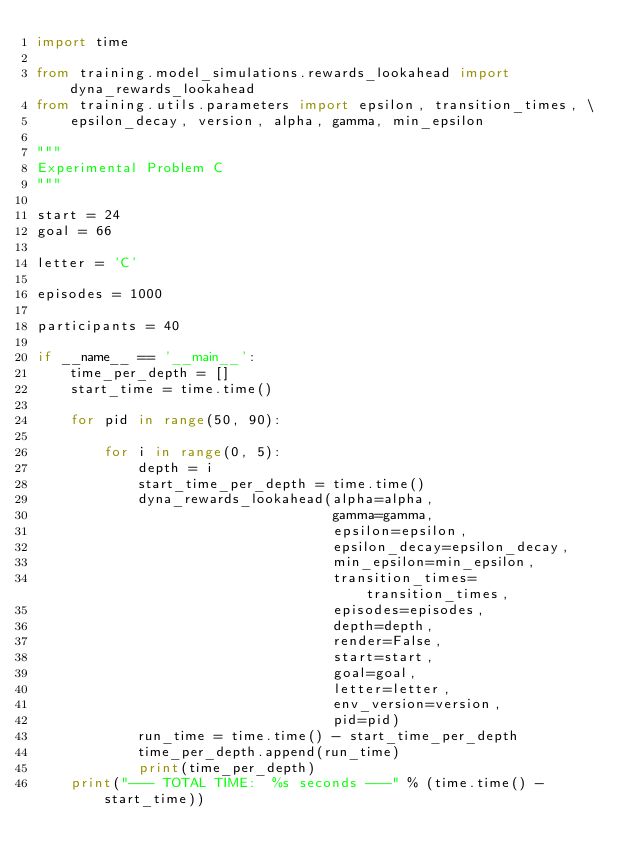<code> <loc_0><loc_0><loc_500><loc_500><_Python_>import time

from training.model_simulations.rewards_lookahead import dyna_rewards_lookahead
from training.utils.parameters import epsilon, transition_times, \
    epsilon_decay, version, alpha, gamma, min_epsilon

"""
Experimental Problem C
"""

start = 24
goal = 66

letter = 'C'

episodes = 1000

participants = 40

if __name__ == '__main__':
    time_per_depth = []
    start_time = time.time()

    for pid in range(50, 90):

        for i in range(0, 5):
            depth = i
            start_time_per_depth = time.time()
            dyna_rewards_lookahead(alpha=alpha,
                                   gamma=gamma,
                                   epsilon=epsilon,
                                   epsilon_decay=epsilon_decay,
                                   min_epsilon=min_epsilon,
                                   transition_times=transition_times,
                                   episodes=episodes,
                                   depth=depth,
                                   render=False,
                                   start=start,
                                   goal=goal,
                                   letter=letter,
                                   env_version=version,
                                   pid=pid)
            run_time = time.time() - start_time_per_depth
            time_per_depth.append(run_time)
            print(time_per_depth)
    print("--- TOTAL TIME:  %s seconds ---" % (time.time() - start_time))
</code> 